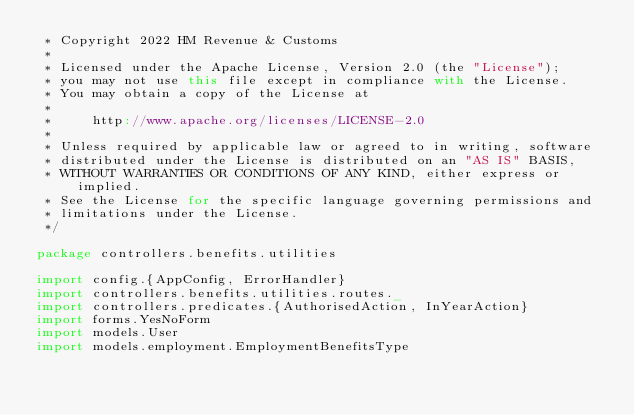<code> <loc_0><loc_0><loc_500><loc_500><_Scala_> * Copyright 2022 HM Revenue & Customs
 *
 * Licensed under the Apache License, Version 2.0 (the "License");
 * you may not use this file except in compliance with the License.
 * You may obtain a copy of the License at
 *
 *     http://www.apache.org/licenses/LICENSE-2.0
 *
 * Unless required by applicable law or agreed to in writing, software
 * distributed under the License is distributed on an "AS IS" BASIS,
 * WITHOUT WARRANTIES OR CONDITIONS OF ANY KIND, either express or implied.
 * See the License for the specific language governing permissions and
 * limitations under the License.
 */

package controllers.benefits.utilities

import config.{AppConfig, ErrorHandler}
import controllers.benefits.utilities.routes._
import controllers.predicates.{AuthorisedAction, InYearAction}
import forms.YesNoForm
import models.User
import models.employment.EmploymentBenefitsType</code> 